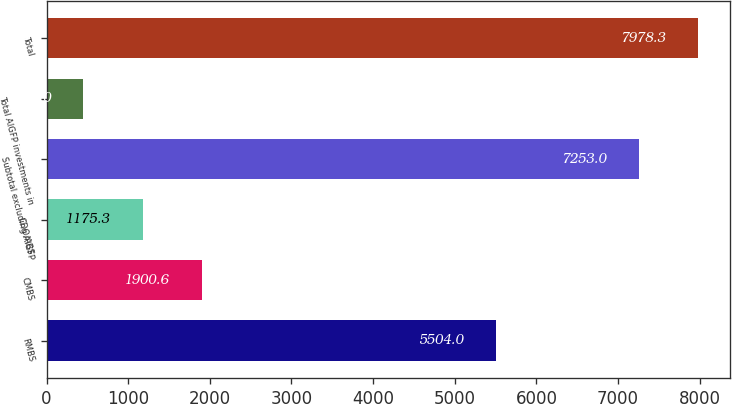Convert chart. <chart><loc_0><loc_0><loc_500><loc_500><bar_chart><fcel>RMBS<fcel>CMBS<fcel>CDO/ABS<fcel>Subtotal excluding AIGFP<fcel>Total AIGFP investments in<fcel>Total<nl><fcel>5504<fcel>1900.6<fcel>1175.3<fcel>7253<fcel>450<fcel>7978.3<nl></chart> 